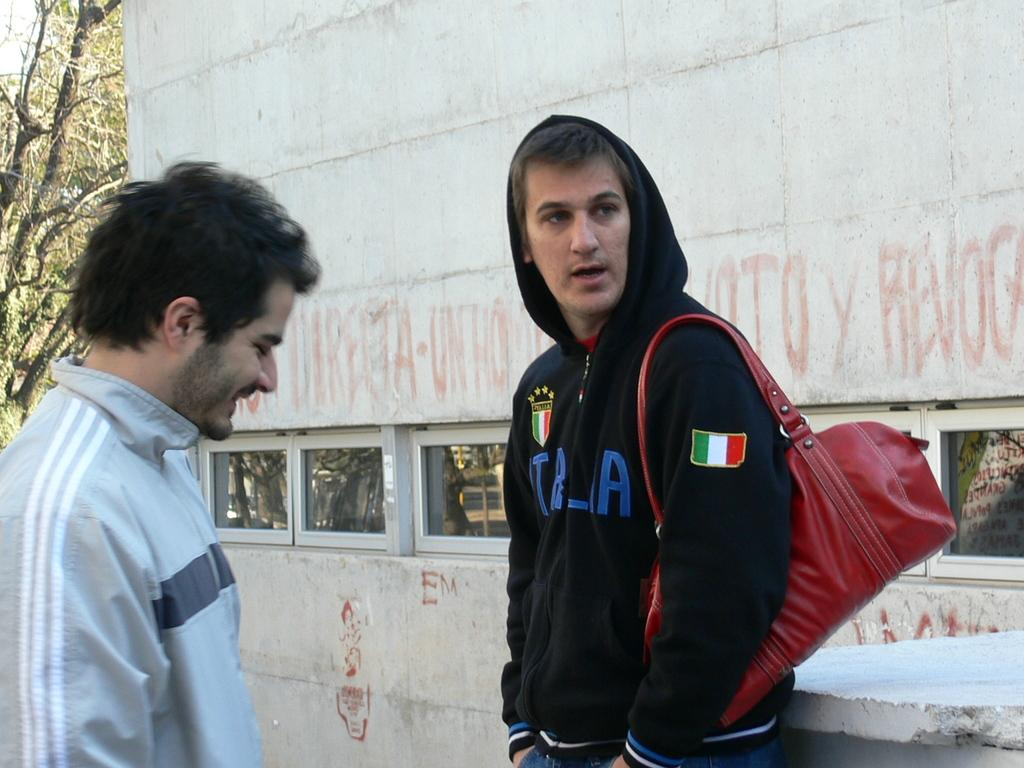Provide a one-sentence caption for the provided image. Man wearing a black sweater with the country Italy labeled on it. 